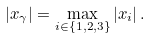Convert formula to latex. <formula><loc_0><loc_0><loc_500><loc_500>| x _ { \gamma } | = \max _ { i \in \{ 1 , 2 , 3 \} } | x _ { i } | \, .</formula> 